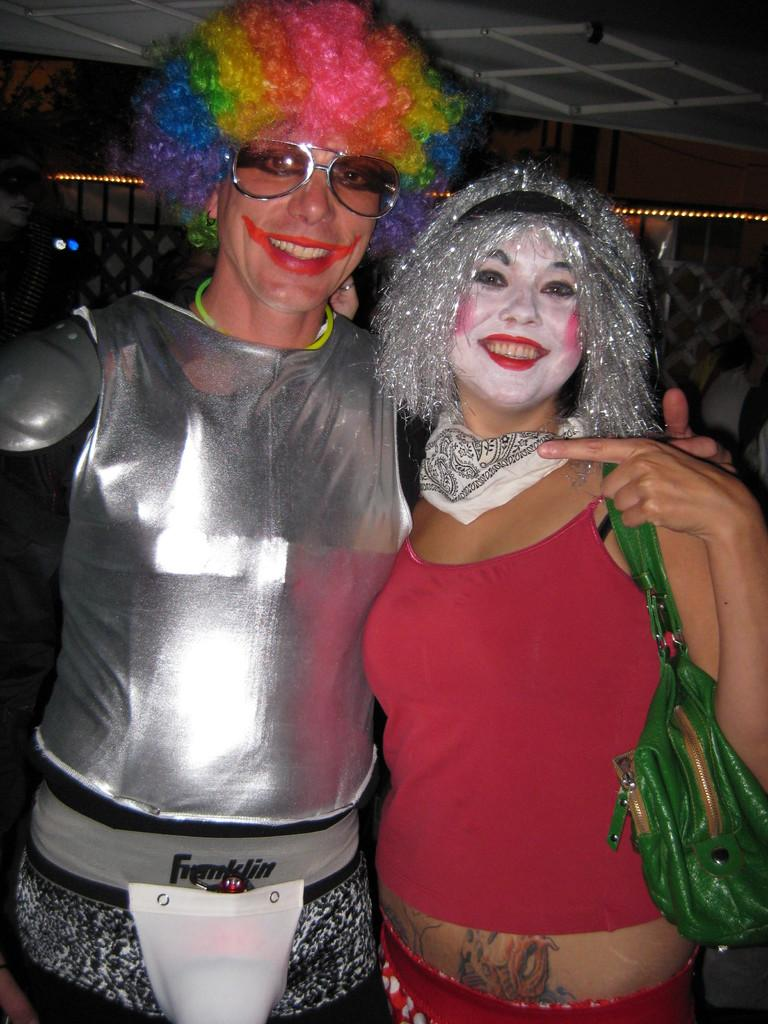How many people are in the image? There are two persons in the image. What are the persons doing in the image? The persons are standing and smiling. What can be seen in the background of the image? There is a railing in the background of the image. What else is visible in the image? There are lights visible in the image. What type of rhythm can be heard coming from the persons in the image? There is no sound or rhythm present in the image; it only shows two people standing and smiling. 